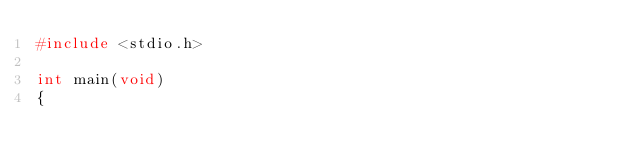<code> <loc_0><loc_0><loc_500><loc_500><_C_>#include <stdio.h>

int main(void)
{</code> 